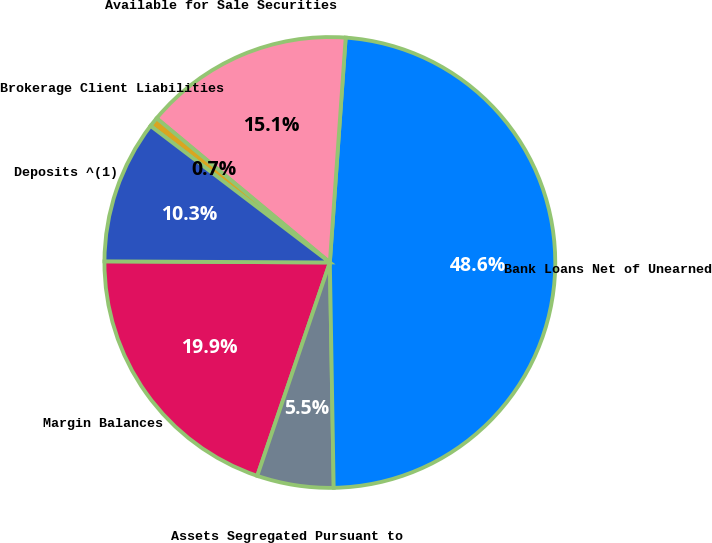Convert chart. <chart><loc_0><loc_0><loc_500><loc_500><pie_chart><fcel>Margin Balances<fcel>Assets Segregated Pursuant to<fcel>Bank Loans Net of Unearned<fcel>Available for Sale Securities<fcel>Brokerage Client Liabilities<fcel>Deposits ^(1)<nl><fcel>19.86%<fcel>5.49%<fcel>48.61%<fcel>15.07%<fcel>0.69%<fcel>10.28%<nl></chart> 